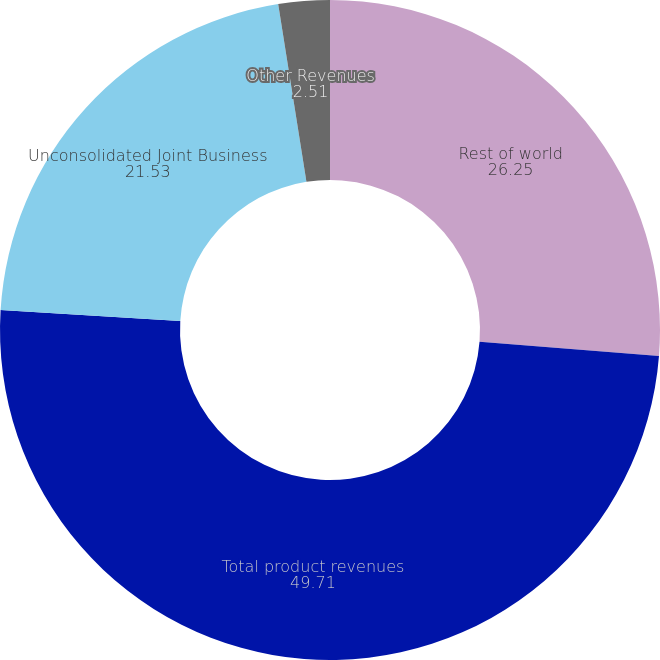<chart> <loc_0><loc_0><loc_500><loc_500><pie_chart><fcel>Rest of world<fcel>Total product revenues<fcel>Unconsolidated Joint Business<fcel>Other Revenues<nl><fcel>26.25%<fcel>49.71%<fcel>21.53%<fcel>2.51%<nl></chart> 